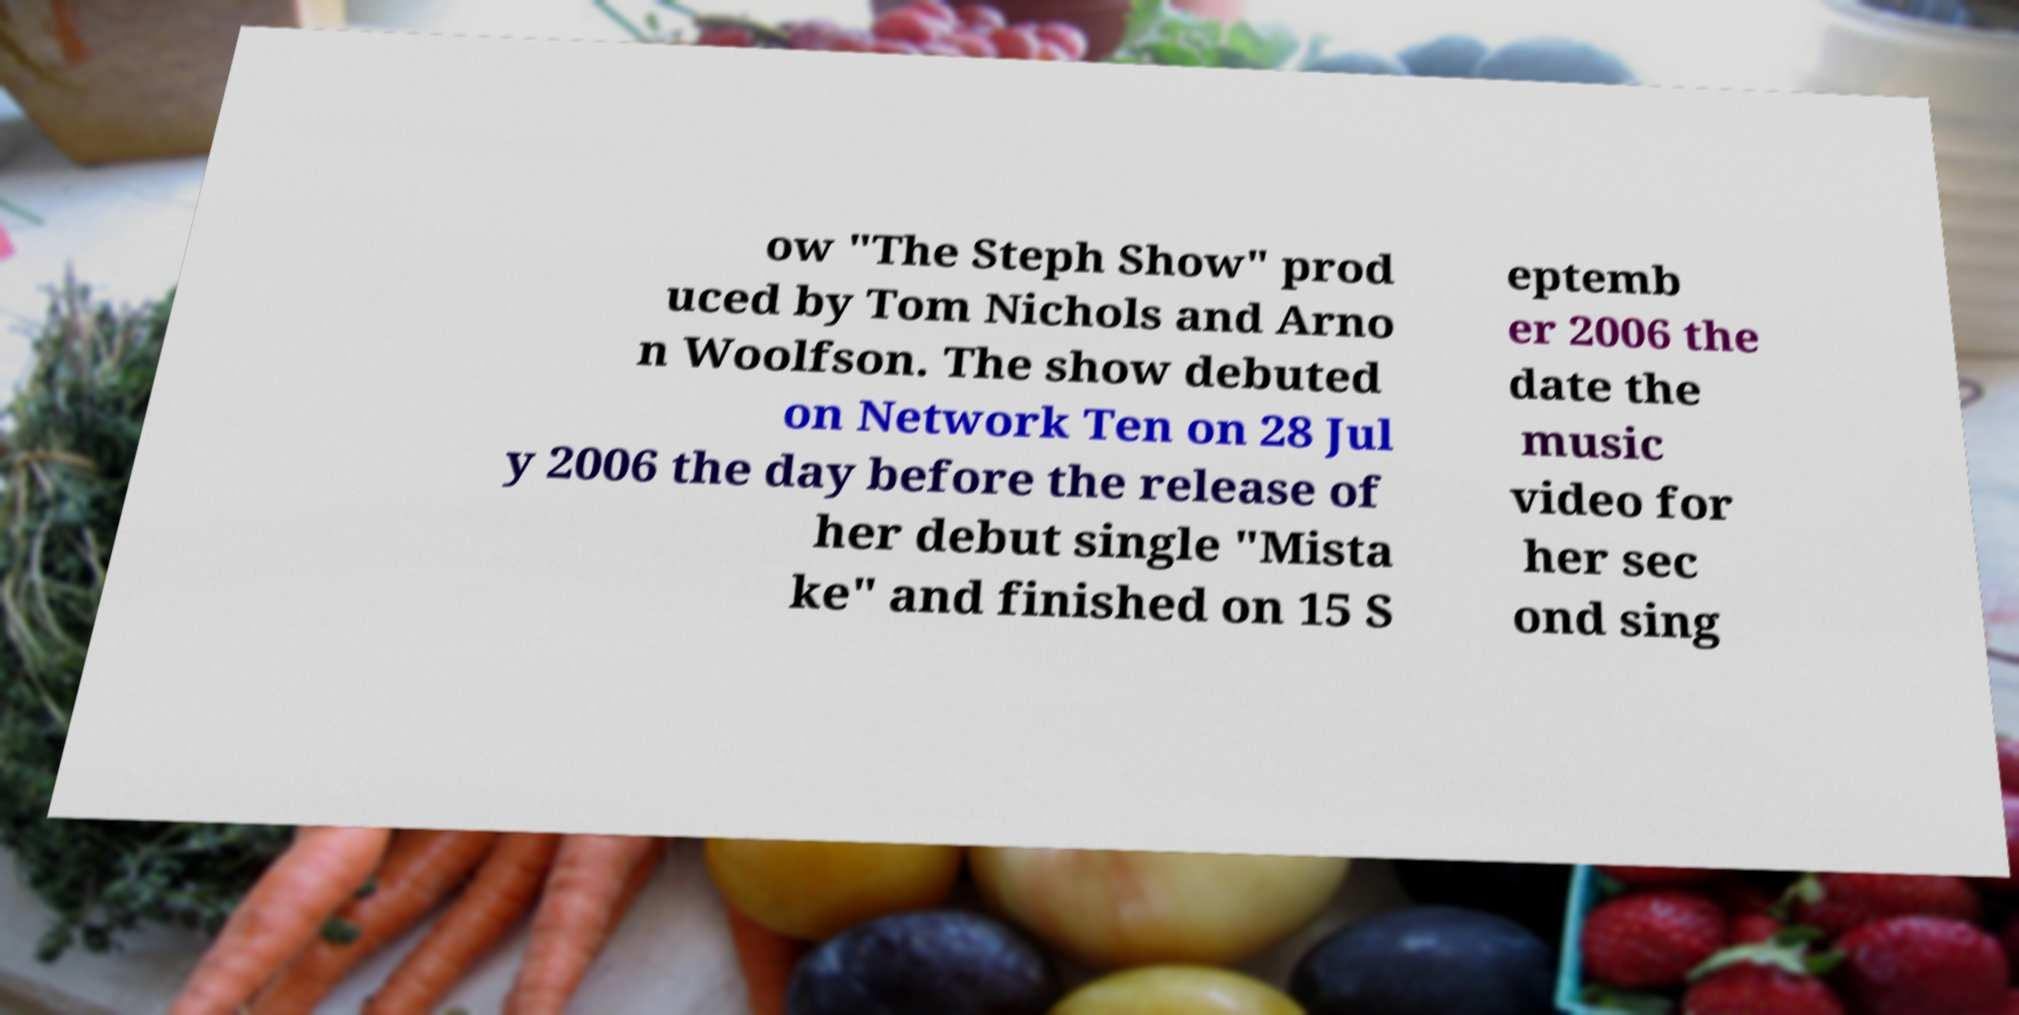Could you assist in decoding the text presented in this image and type it out clearly? ow "The Steph Show" prod uced by Tom Nichols and Arno n Woolfson. The show debuted on Network Ten on 28 Jul y 2006 the day before the release of her debut single "Mista ke" and finished on 15 S eptemb er 2006 the date the music video for her sec ond sing 